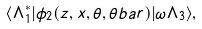<formula> <loc_0><loc_0><loc_500><loc_500>\langle \Lambda ^ { * } _ { 1 } | \phi _ { 2 } ( z , x , \theta , \theta b a r ) | \omega \Lambda _ { 3 } \rangle ,</formula> 